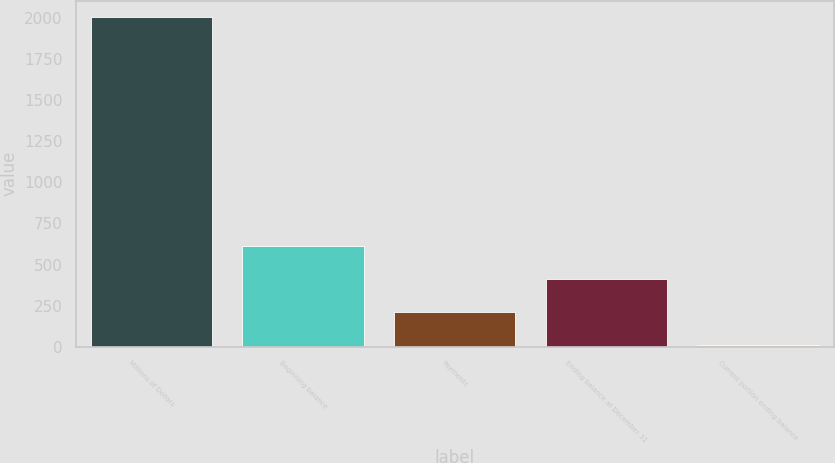<chart> <loc_0><loc_0><loc_500><loc_500><bar_chart><fcel>Millions of Dollars<fcel>Beginning balance<fcel>Payments<fcel>Ending balance at December 31<fcel>Current portion ending balance<nl><fcel>2007<fcel>609.8<fcel>210.6<fcel>410.2<fcel>11<nl></chart> 